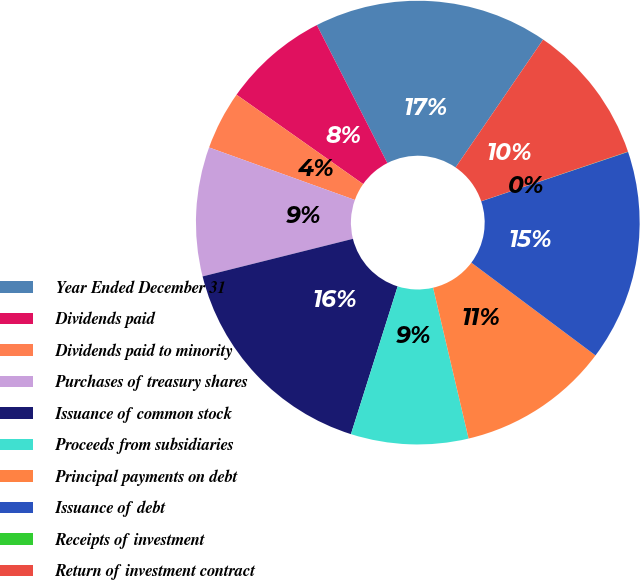Convert chart. <chart><loc_0><loc_0><loc_500><loc_500><pie_chart><fcel>Year Ended December 31<fcel>Dividends paid<fcel>Dividends paid to minority<fcel>Purchases of treasury shares<fcel>Issuance of common stock<fcel>Proceeds from subsidiaries<fcel>Principal payments on debt<fcel>Issuance of debt<fcel>Receipts of investment<fcel>Return of investment contract<nl><fcel>17.08%<fcel>7.7%<fcel>4.28%<fcel>9.4%<fcel>16.23%<fcel>8.55%<fcel>11.11%<fcel>15.38%<fcel>0.02%<fcel>10.26%<nl></chart> 